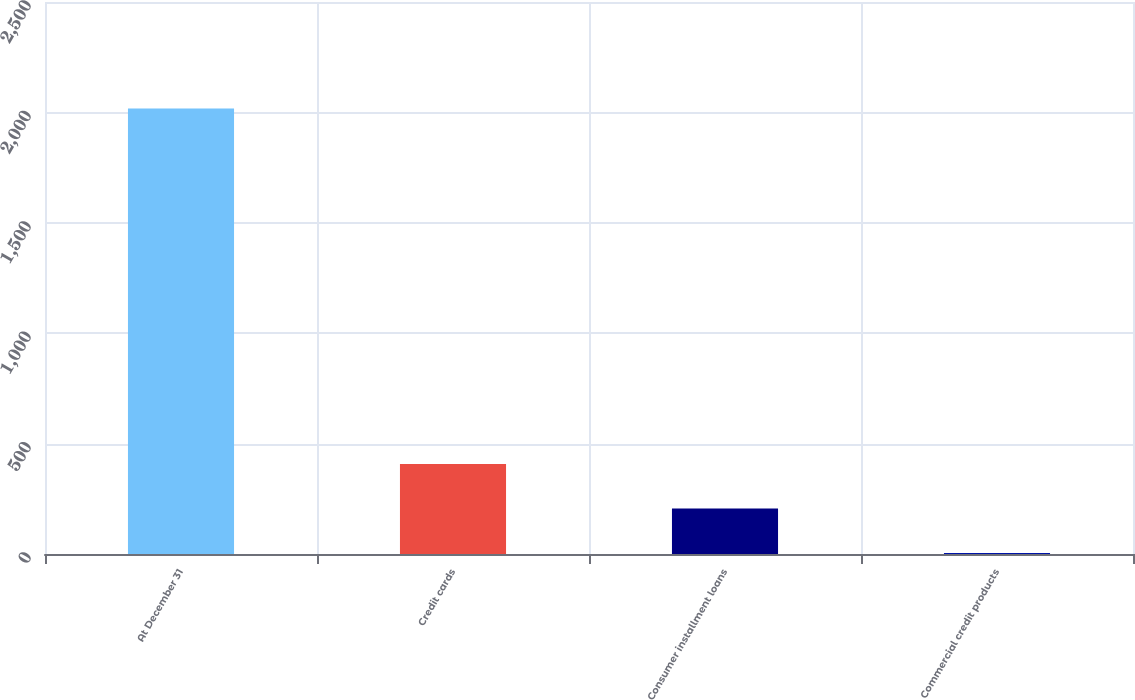Convert chart to OTSL. <chart><loc_0><loc_0><loc_500><loc_500><bar_chart><fcel>At December 31<fcel>Credit cards<fcel>Consumer installment loans<fcel>Commercial credit products<nl><fcel>2018<fcel>407.6<fcel>206.3<fcel>5<nl></chart> 